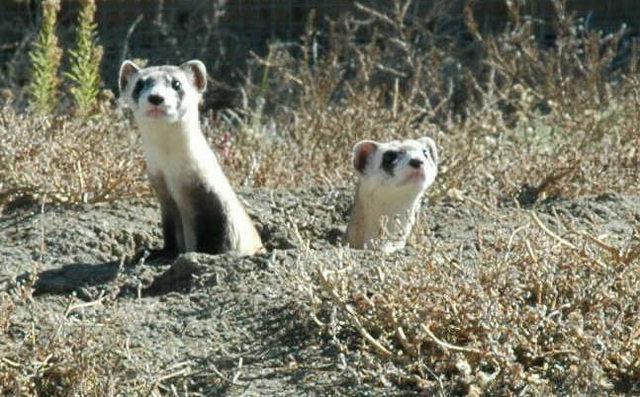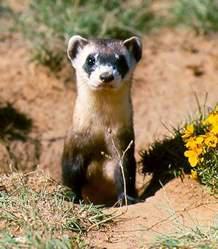The first image is the image on the left, the second image is the image on the right. Assess this claim about the two images: "There are exactly two ferrets.". Correct or not? Answer yes or no. No. The first image is the image on the left, the second image is the image on the right. Examine the images to the left and right. Is the description "The left image contains no more than one ferret." accurate? Answer yes or no. No. 